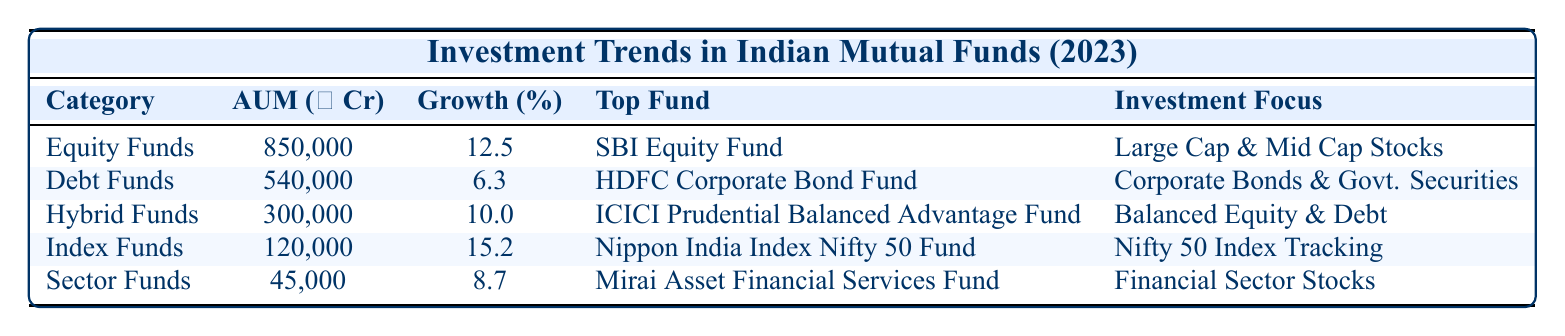What is the AUM of Equity Funds? The AUM for the "Equity Funds" category is provided directly in the table under the "AUM (in ₹ Crores)" column, which states 850000.
Answer: 850000 Which fund has the highest growth rate among the listed categories? Looking at the "Growth Rate (%)" column, the highest value is 15.2%, which belongs to "Index Funds."
Answer: Index Funds Are there any funds focused solely on government securities? Examining the investment focus of each category, only "Debt Funds" mention "Government Securities" as part of their focus.
Answer: Yes What is the difference in AUM between Debt Funds and Sector Funds? The AUM for Debt Funds is 540000, and for Sector Funds, it is 45000. The difference is calculated as 540000 - 45000 = 495000.
Answer: 495000 Which fund has an investment focus on large-cap and mid-cap stocks? The table clearly states that "SBI Equity Fund," listed under "Equity Funds," has an investment focus on "Large Cap & Mid Cap Stocks."
Answer: SBI Equity Fund What is the combined AUM of Hybrid Funds and Index Funds? For "Hybrid Funds," the AUM is 300000, and for "Index Funds," it is 120000. Adding these values gives 300000 + 120000 = 420000.
Answer: 420000 Is there a fund that has both equity and debt in its investment focus? "Hybrid Funds" explicitly state "Balanced Equity & Debt" in their focus, indicating both are included.
Answer: Yes Which category experienced the lowest growth rate? By comparing the "Growth Rate (%)" column, the lowest value is 6.3%, which corresponds to "Debt Funds."
Answer: Debt Funds What percentage of AUM does Sector Funds contribute compared to Equity Funds? AUM for Sector Funds is 45000 and for Equity Funds is 850000. The percentage is (45000 / 850000) * 100 = 5.29%.
Answer: 5.29% 